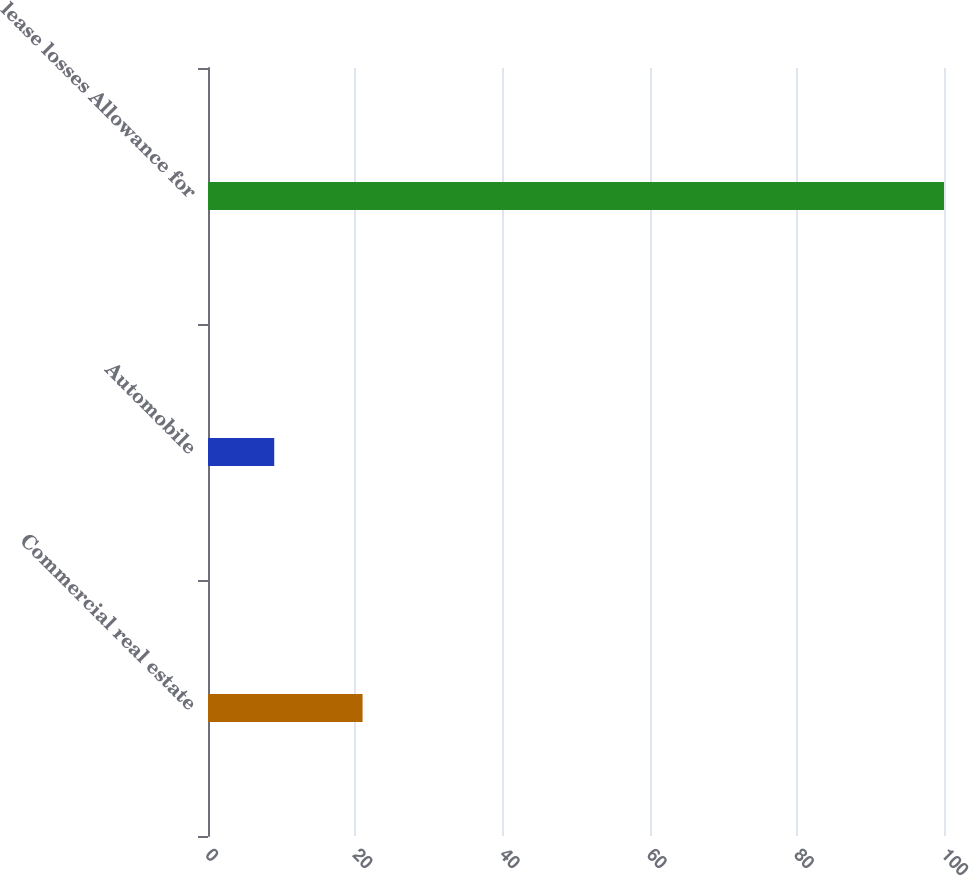Convert chart to OTSL. <chart><loc_0><loc_0><loc_500><loc_500><bar_chart><fcel>Commercial real estate<fcel>Automobile<fcel>lease losses Allowance for<nl><fcel>21<fcel>9<fcel>100<nl></chart> 